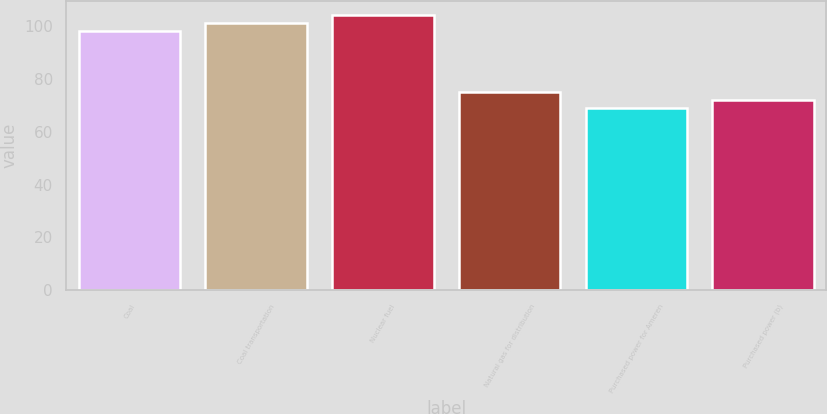Convert chart to OTSL. <chart><loc_0><loc_0><loc_500><loc_500><bar_chart><fcel>Coal<fcel>Coal transportation<fcel>Nuclear fuel<fcel>Natural gas for distribution<fcel>Purchased power for Ameren<fcel>Purchased power (b)<nl><fcel>98<fcel>101.1<fcel>104.2<fcel>75.2<fcel>69<fcel>72.1<nl></chart> 